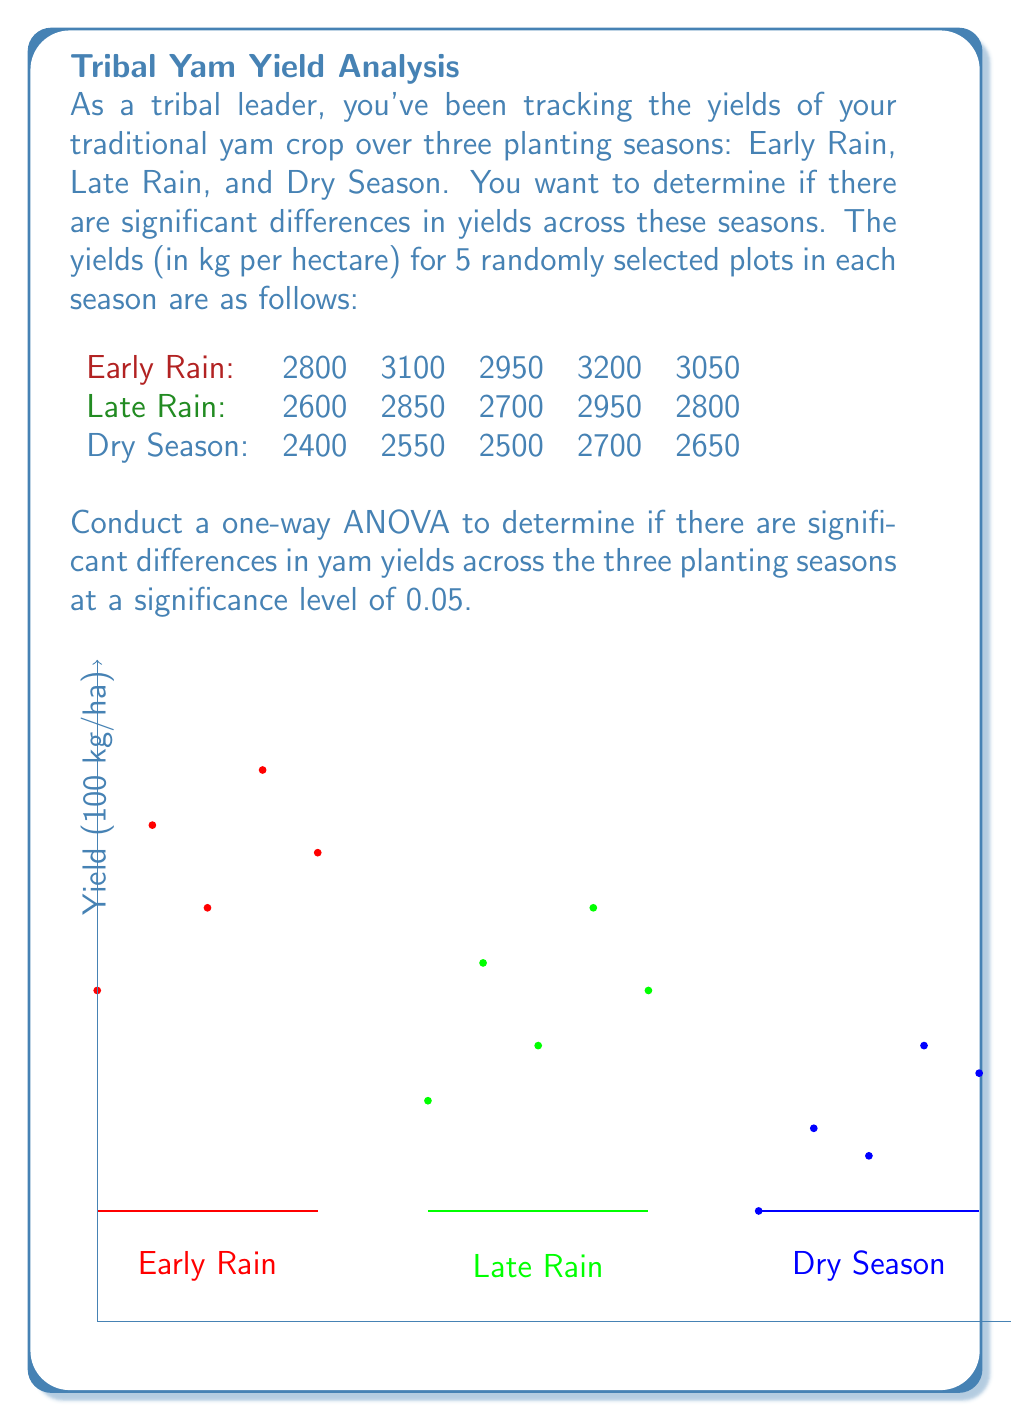Could you help me with this problem? To conduct a one-way ANOVA, we'll follow these steps:

1) Calculate the sum of squares (SS) for between groups, within groups, and total.
2) Calculate the degrees of freedom (df) for between groups, within groups, and total.
3) Calculate the mean squares (MS) for between groups and within groups.
4) Calculate the F-statistic.
5) Compare the F-statistic to the critical F-value.

Step 1: Calculate SS

a) Total SS:
$SS_{total} = \sum (x - \bar{x})^2$
Where $\bar{x}$ is the grand mean.

Grand mean $\bar{x} = \frac{2800 + 3100 + ... + 2650}{15} = 2853.33$

$SS_{total} = (2800 - 2853.33)^2 + (3100 - 2853.33)^2 + ... + (2650 - 2853.33)^2 = 1,010,000$

b) Between SS:
$SS_{between} = \sum n_i(\bar{x}_i - \bar{x})^2$
Where $n_i$ is the number of observations in each group and $\bar{x}_i$ is the mean of each group.

$\bar{x}_{Early} = 3020$, $\bar{x}_{Late} = 2780$, $\bar{x}_{Dry} = 2560$

$SS_{between} = 5(3020 - 2853.33)^2 + 5(2780 - 2853.33)^2 + 5(2560 - 2853.33)^2 = 690,000$

c) Within SS:
$SS_{within} = SS_{total} - SS_{between} = 1,010,000 - 690,000 = 320,000$

Step 2: Calculate df

$df_{between} = k - 1 = 3 - 1 = 2$ (where k is the number of groups)
$df_{within} = N - k = 15 - 3 = 12$ (where N is the total number of observations)
$df_{total} = N - 1 = 15 - 1 = 14$

Step 3: Calculate MS

$MS_{between} = \frac{SS_{between}}{df_{between}} = \frac{690,000}{2} = 345,000$
$MS_{within} = \frac{SS_{within}}{df_{within}} = \frac{320,000}{12} = 26,666.67$

Step 4: Calculate F-statistic

$F = \frac{MS_{between}}{MS_{within}} = \frac{345,000}{26,666.67} = 12.94$

Step 5: Compare to critical F-value

For $\alpha = 0.05$, $df_{between} = 2$, and $df_{within} = 12$, the critical F-value is approximately 3.89.

Since our calculated F-statistic (12.94) is greater than the critical F-value (3.89), we reject the null hypothesis.
Answer: $F(2,12) = 12.94, p < 0.05$. Significant differences exist in yam yields across planting seasons. 